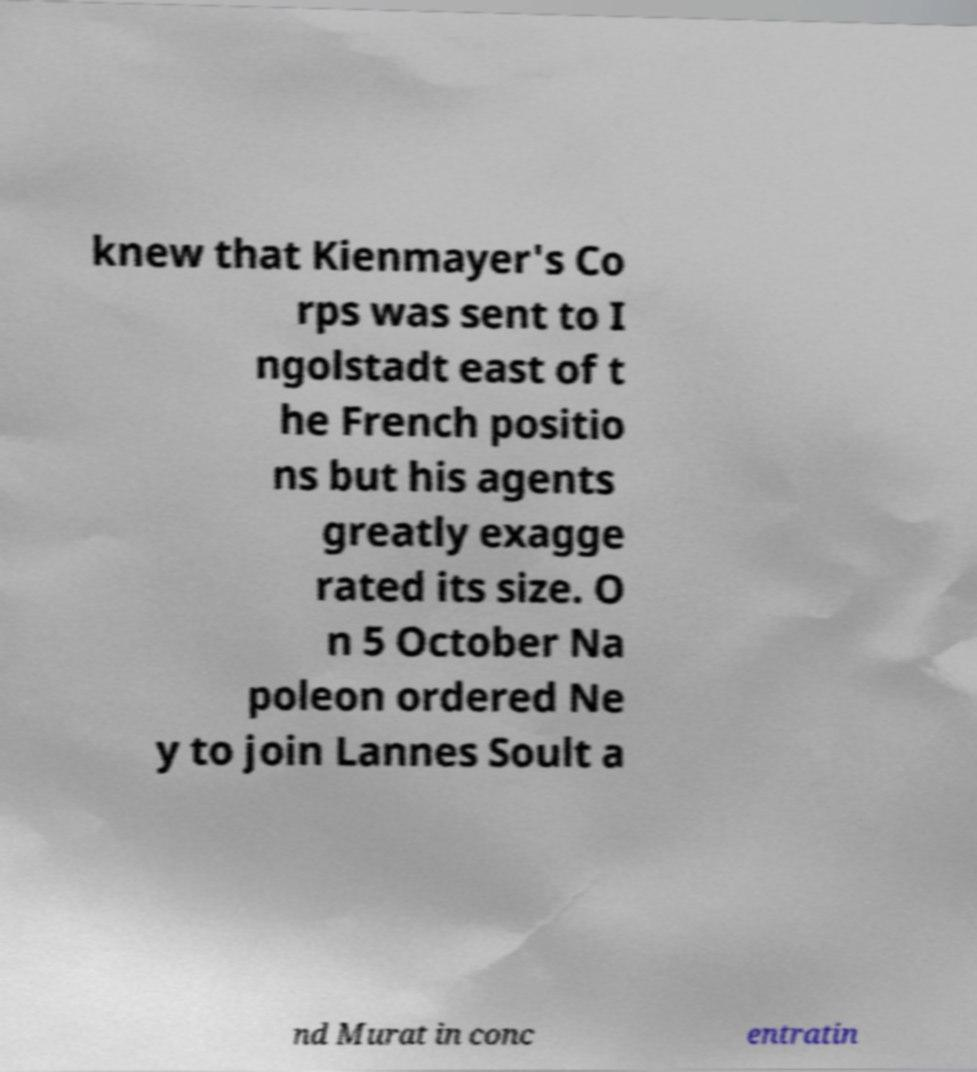I need the written content from this picture converted into text. Can you do that? knew that Kienmayer's Co rps was sent to I ngolstadt east of t he French positio ns but his agents greatly exagge rated its size. O n 5 October Na poleon ordered Ne y to join Lannes Soult a nd Murat in conc entratin 